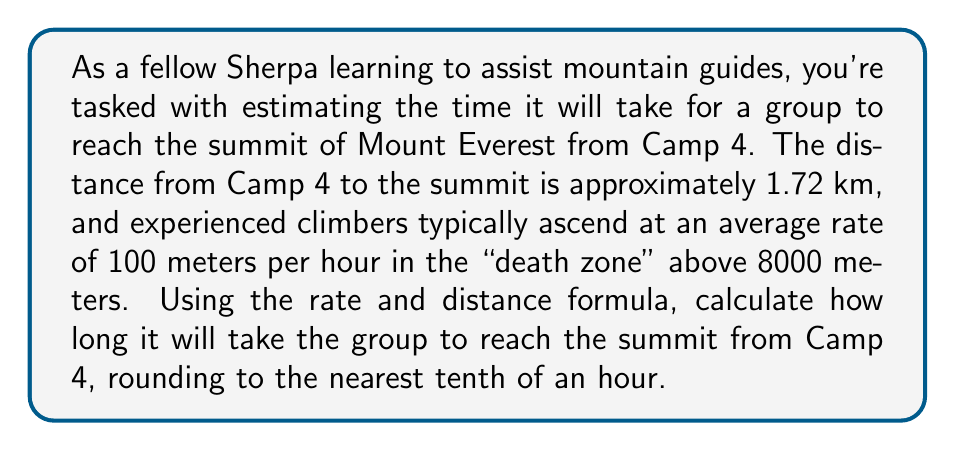Provide a solution to this math problem. To solve this problem, we'll use the rate and distance formula:

$$\text{Time} = \frac{\text{Distance}}{\text{Rate}}$$

Let's break down the given information:
1. Distance from Camp 4 to summit: 1.72 km = 1720 meters
2. Climbing rate: 100 meters per hour

Now, let's plug these values into our formula:

$$\text{Time} = \frac{1720 \text{ meters}}{100 \text{ meters/hour}}$$

Simplifying:

$$\text{Time} = 17.2 \text{ hours}$$

Rounding to the nearest tenth of an hour:

$$\text{Time} \approx 17.2 \text{ hours}$$
Answer: 17.2 hours 